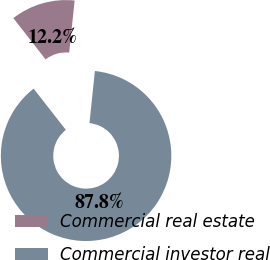Convert chart. <chart><loc_0><loc_0><loc_500><loc_500><pie_chart><fcel>Commercial real estate<fcel>Commercial investor real<nl><fcel>12.2%<fcel>87.8%<nl></chart> 